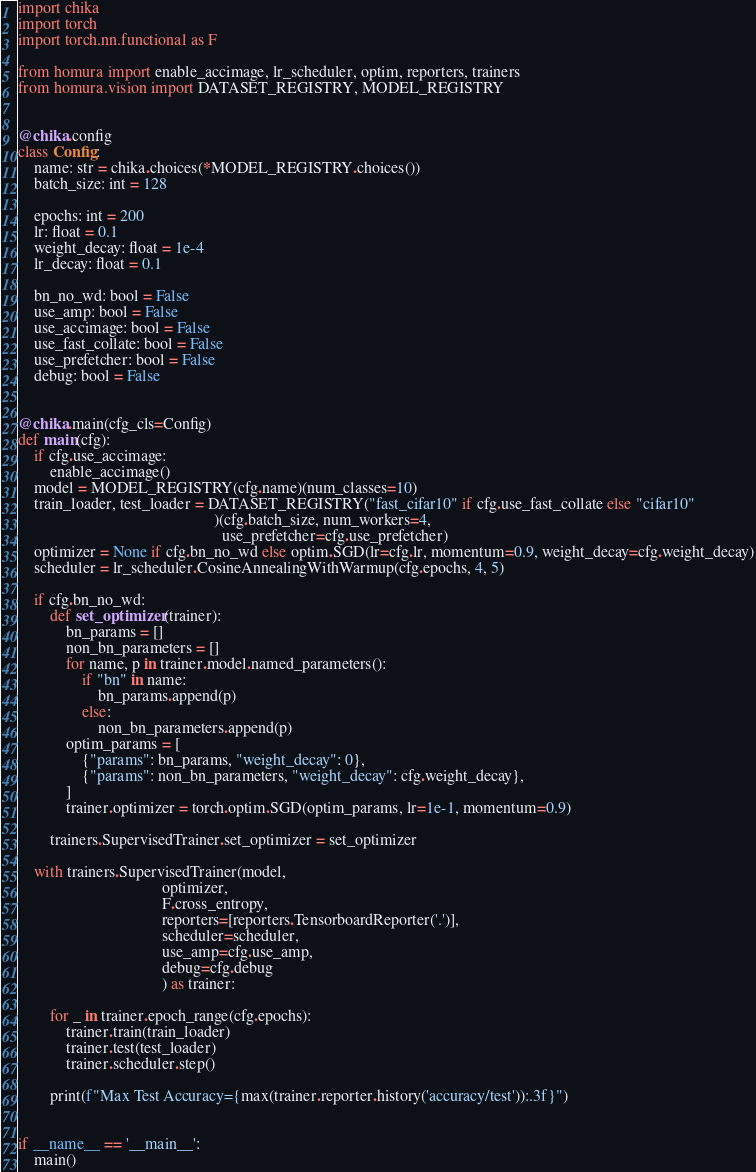<code> <loc_0><loc_0><loc_500><loc_500><_Python_>import chika
import torch
import torch.nn.functional as F

from homura import enable_accimage, lr_scheduler, optim, reporters, trainers
from homura.vision import DATASET_REGISTRY, MODEL_REGISTRY


@chika.config
class Config:
    name: str = chika.choices(*MODEL_REGISTRY.choices())
    batch_size: int = 128

    epochs: int = 200
    lr: float = 0.1
    weight_decay: float = 1e-4
    lr_decay: float = 0.1

    bn_no_wd: bool = False
    use_amp: bool = False
    use_accimage: bool = False
    use_fast_collate: bool = False
    use_prefetcher: bool = False
    debug: bool = False


@chika.main(cfg_cls=Config)
def main(cfg):
    if cfg.use_accimage:
        enable_accimage()
    model = MODEL_REGISTRY(cfg.name)(num_classes=10)
    train_loader, test_loader = DATASET_REGISTRY("fast_cifar10" if cfg.use_fast_collate else "cifar10"
                                                 )(cfg.batch_size, num_workers=4,
                                                   use_prefetcher=cfg.use_prefetcher)
    optimizer = None if cfg.bn_no_wd else optim.SGD(lr=cfg.lr, momentum=0.9, weight_decay=cfg.weight_decay)
    scheduler = lr_scheduler.CosineAnnealingWithWarmup(cfg.epochs, 4, 5)

    if cfg.bn_no_wd:
        def set_optimizer(trainer):
            bn_params = []
            non_bn_parameters = []
            for name, p in trainer.model.named_parameters():
                if "bn" in name:
                    bn_params.append(p)
                else:
                    non_bn_parameters.append(p)
            optim_params = [
                {"params": bn_params, "weight_decay": 0},
                {"params": non_bn_parameters, "weight_decay": cfg.weight_decay},
            ]
            trainer.optimizer = torch.optim.SGD(optim_params, lr=1e-1, momentum=0.9)

        trainers.SupervisedTrainer.set_optimizer = set_optimizer

    with trainers.SupervisedTrainer(model,
                                    optimizer,
                                    F.cross_entropy,
                                    reporters=[reporters.TensorboardReporter('.')],
                                    scheduler=scheduler,
                                    use_amp=cfg.use_amp,
                                    debug=cfg.debug
                                    ) as trainer:

        for _ in trainer.epoch_range(cfg.epochs):
            trainer.train(train_loader)
            trainer.test(test_loader)
            trainer.scheduler.step()

        print(f"Max Test Accuracy={max(trainer.reporter.history('accuracy/test')):.3f}")


if __name__ == '__main__':
    main()
</code> 